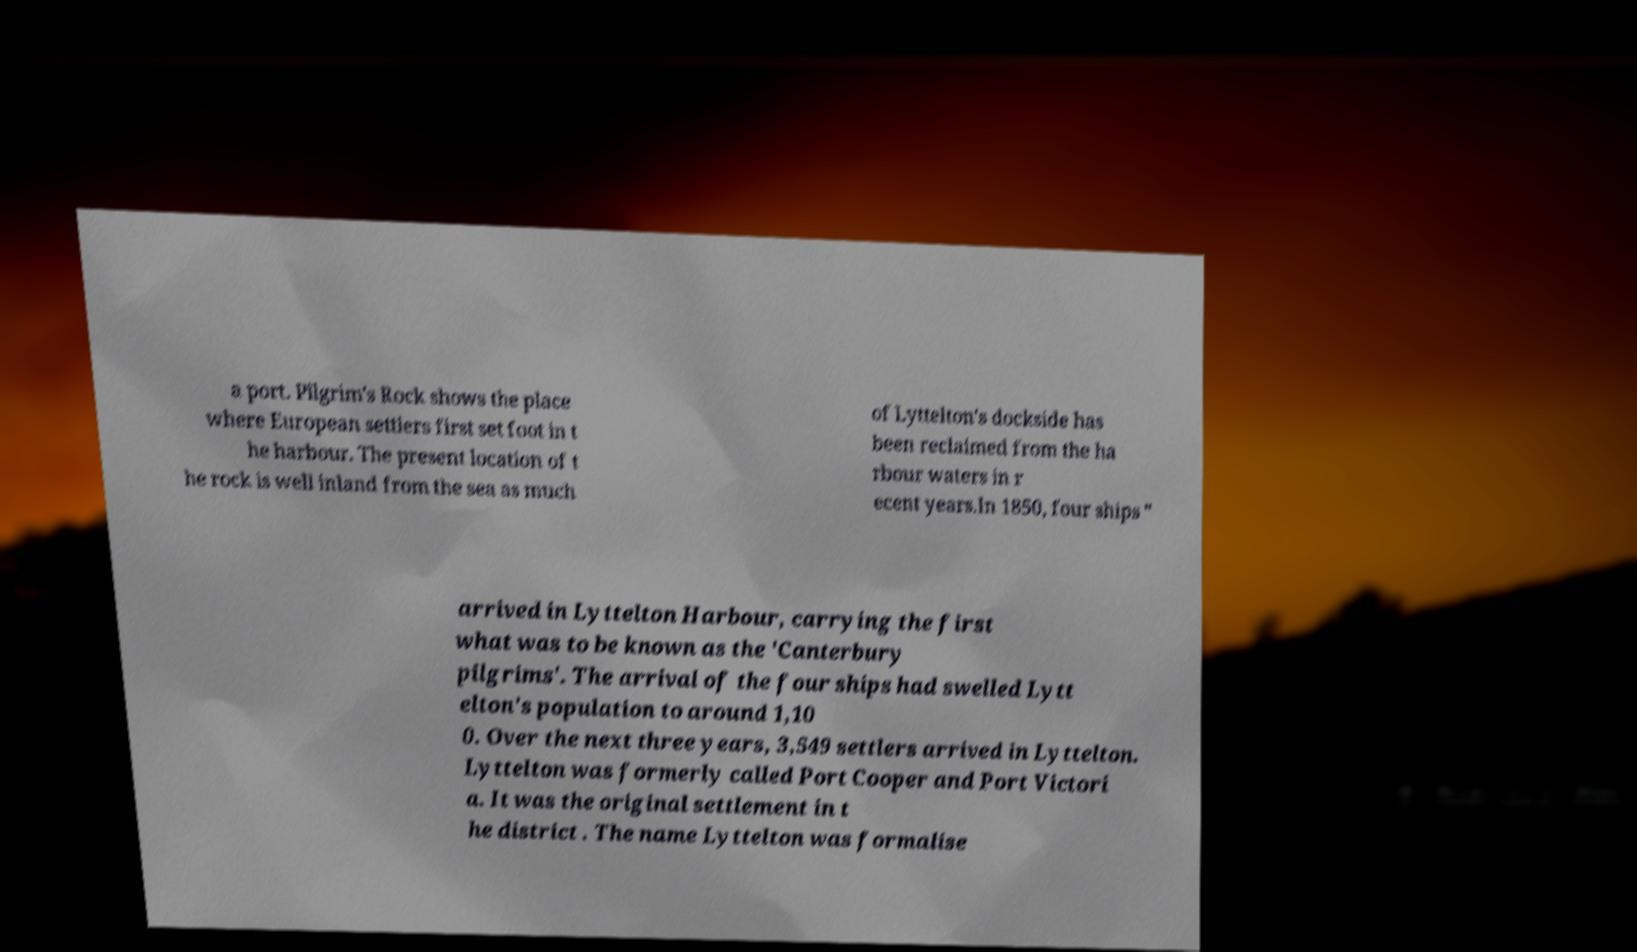Could you assist in decoding the text presented in this image and type it out clearly? a port. Pilgrim's Rock shows the place where European settlers first set foot in t he harbour. The present location of t he rock is well inland from the sea as much of Lyttelton's dockside has been reclaimed from the ha rbour waters in r ecent years.In 1850, four ships " arrived in Lyttelton Harbour, carrying the first what was to be known as the 'Canterbury pilgrims'. The arrival of the four ships had swelled Lytt elton's population to around 1,10 0. Over the next three years, 3,549 settlers arrived in Lyttelton. Lyttelton was formerly called Port Cooper and Port Victori a. It was the original settlement in t he district . The name Lyttelton was formalise 